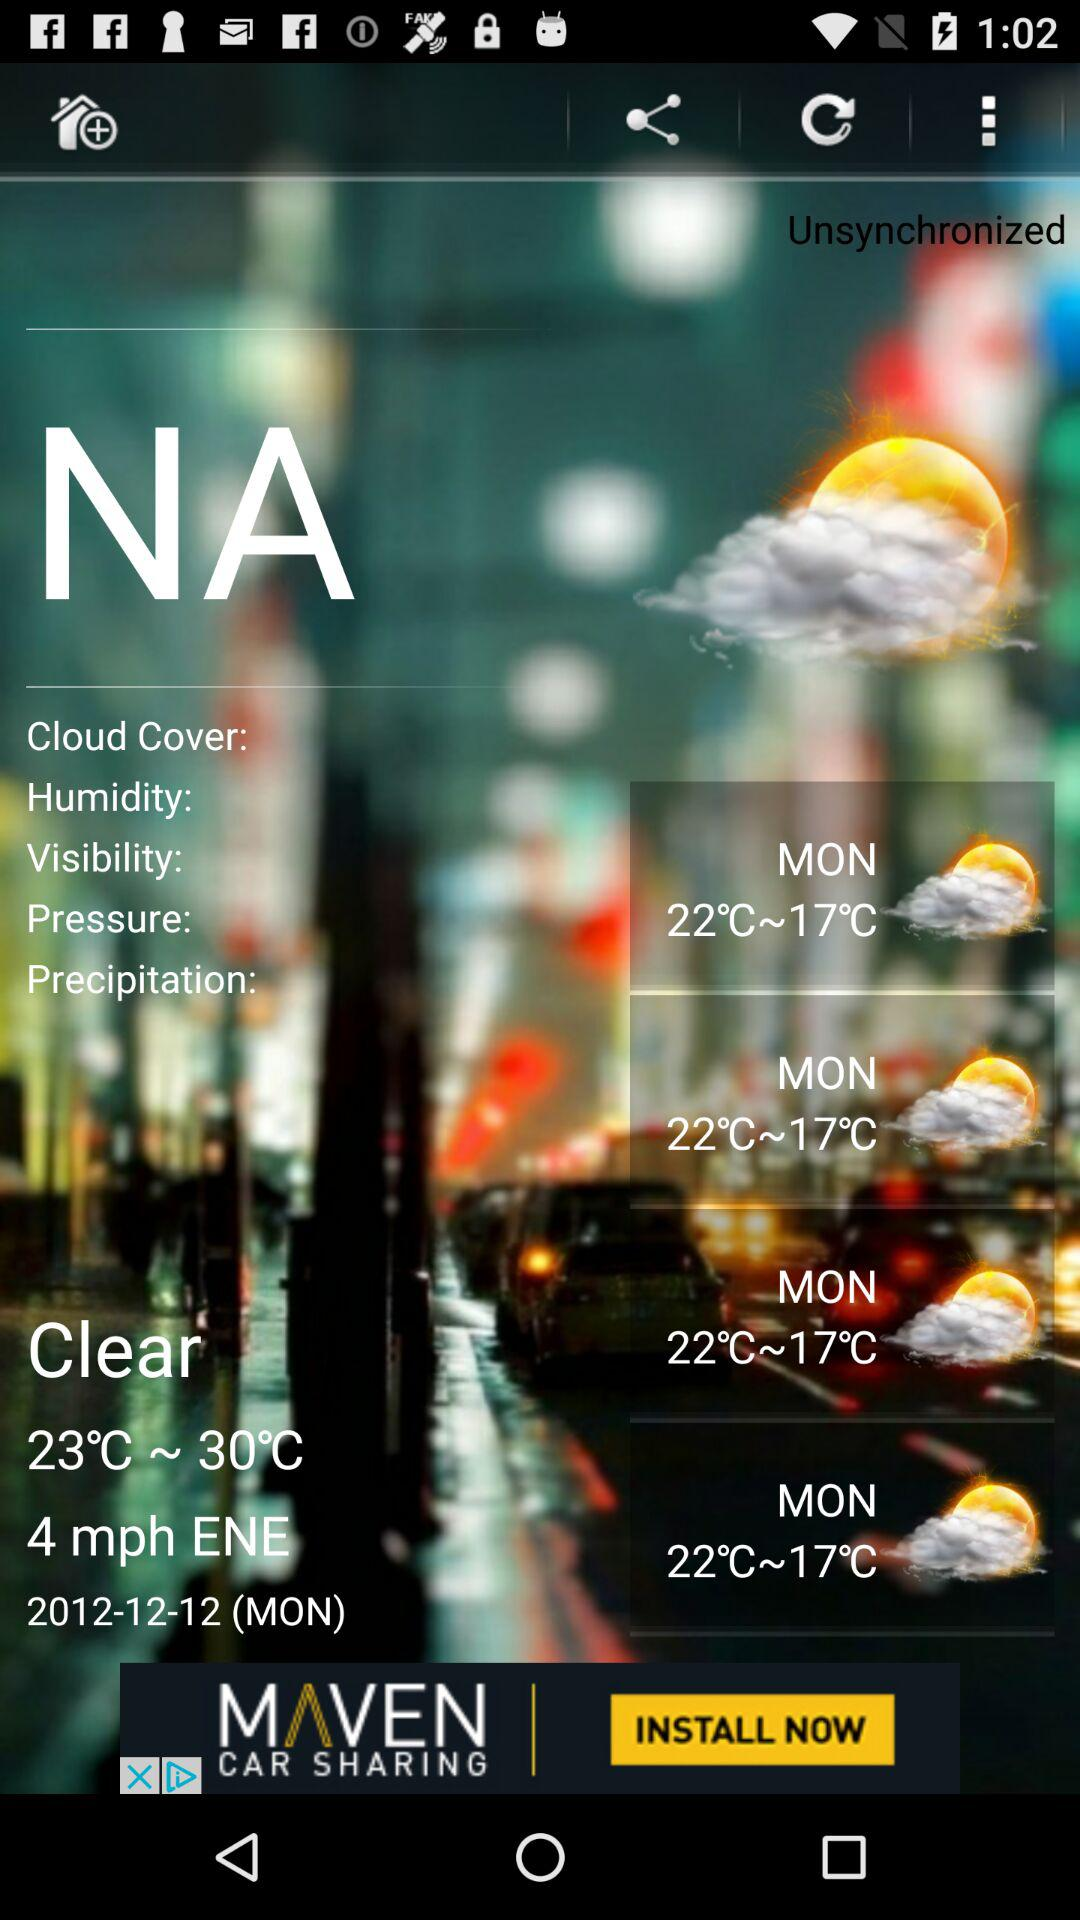For which day is the temperature shown on the screen? The temperature shown on the screen is for Monday. 